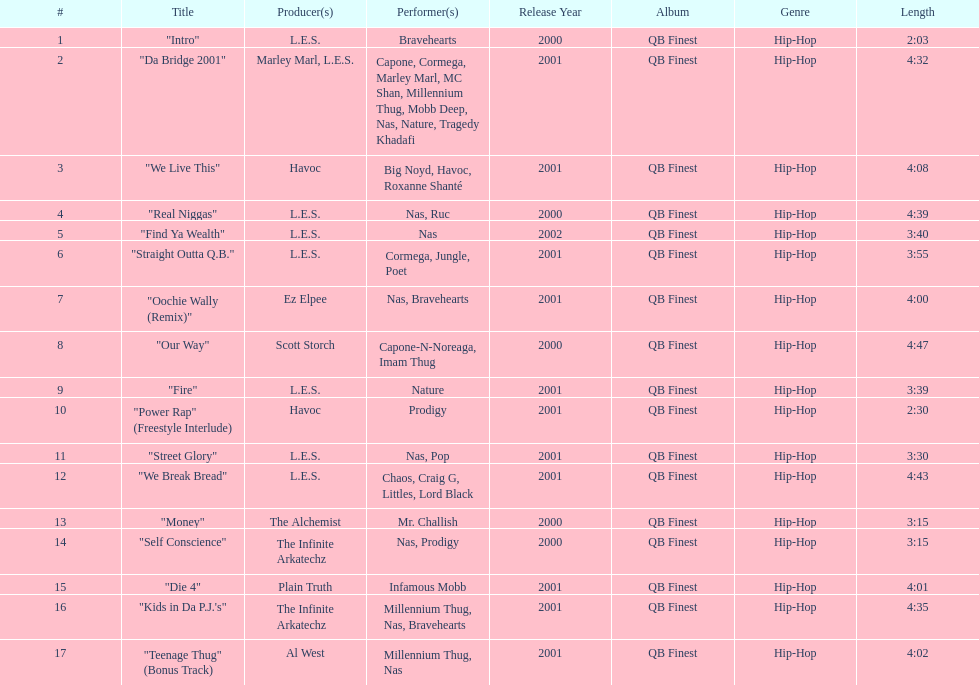How many songs were on the track list? 17. 